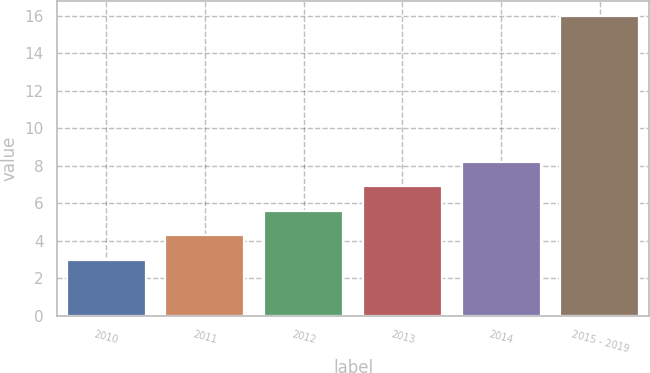Convert chart. <chart><loc_0><loc_0><loc_500><loc_500><bar_chart><fcel>2010<fcel>2011<fcel>2012<fcel>2013<fcel>2014<fcel>2015 - 2019<nl><fcel>3<fcel>4.3<fcel>5.6<fcel>6.9<fcel>8.2<fcel>16<nl></chart> 